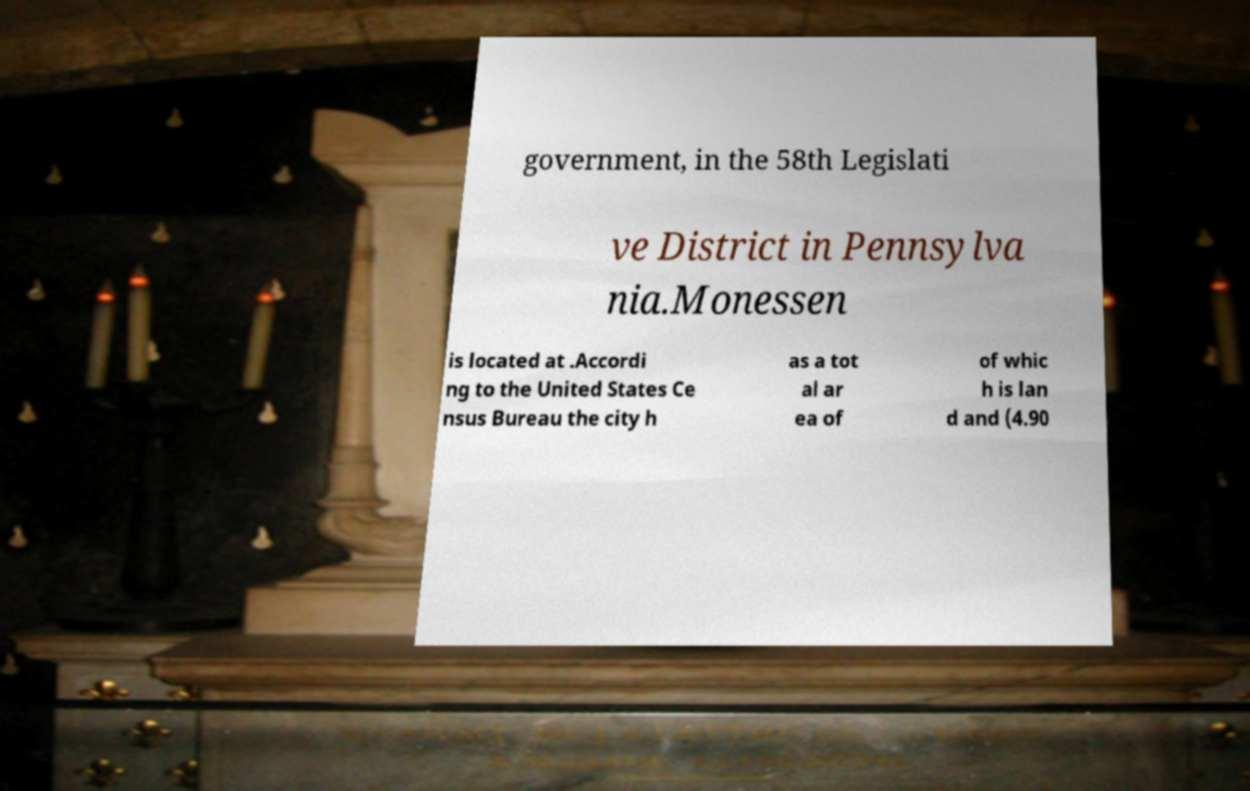For documentation purposes, I need the text within this image transcribed. Could you provide that? government, in the 58th Legislati ve District in Pennsylva nia.Monessen is located at .Accordi ng to the United States Ce nsus Bureau the city h as a tot al ar ea of of whic h is lan d and (4.90 